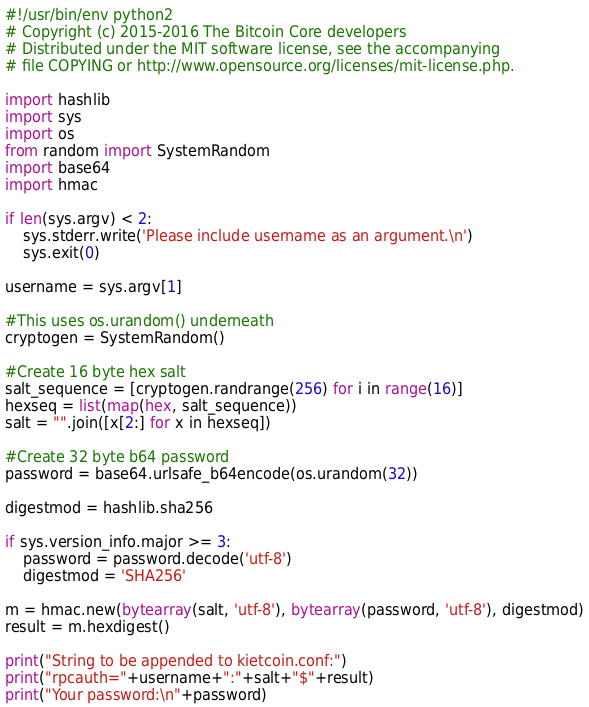Convert code to text. <code><loc_0><loc_0><loc_500><loc_500><_Python_>#!/usr/bin/env python2 
# Copyright (c) 2015-2016 The Bitcoin Core developers
# Distributed under the MIT software license, see the accompanying 
# file COPYING or http://www.opensource.org/licenses/mit-license.php.

import hashlib
import sys
import os
from random import SystemRandom
import base64
import hmac

if len(sys.argv) < 2:
    sys.stderr.write('Please include username as an argument.\n')
    sys.exit(0)

username = sys.argv[1]

#This uses os.urandom() underneath
cryptogen = SystemRandom()

#Create 16 byte hex salt
salt_sequence = [cryptogen.randrange(256) for i in range(16)]
hexseq = list(map(hex, salt_sequence))
salt = "".join([x[2:] for x in hexseq])

#Create 32 byte b64 password
password = base64.urlsafe_b64encode(os.urandom(32))

digestmod = hashlib.sha256

if sys.version_info.major >= 3:
    password = password.decode('utf-8')
    digestmod = 'SHA256'
 
m = hmac.new(bytearray(salt, 'utf-8'), bytearray(password, 'utf-8'), digestmod)
result = m.hexdigest()

print("String to be appended to kietcoin.conf:")
print("rpcauth="+username+":"+salt+"$"+result)
print("Your password:\n"+password)
</code> 